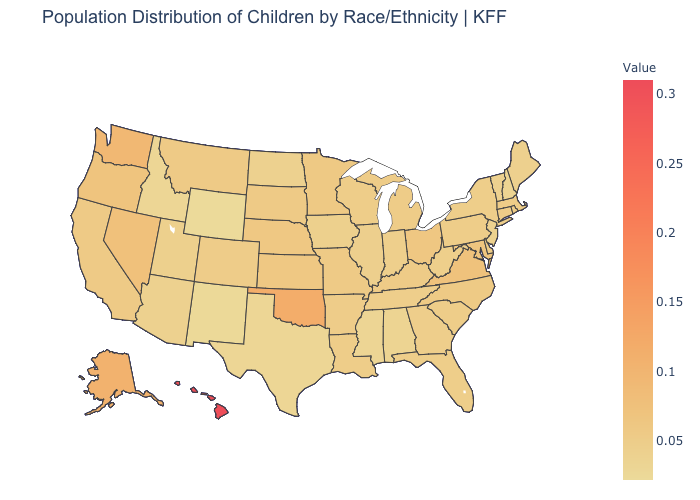Does Montana have a higher value than Wyoming?
Be succinct. Yes. Among the states that border Connecticut , which have the highest value?
Write a very short answer. Massachusetts, Rhode Island. Among the states that border Indiana , which have the highest value?
Keep it brief. Ohio. Which states have the lowest value in the South?
Concise answer only. Texas. Among the states that border Missouri , does Oklahoma have the highest value?
Short answer required. Yes. 